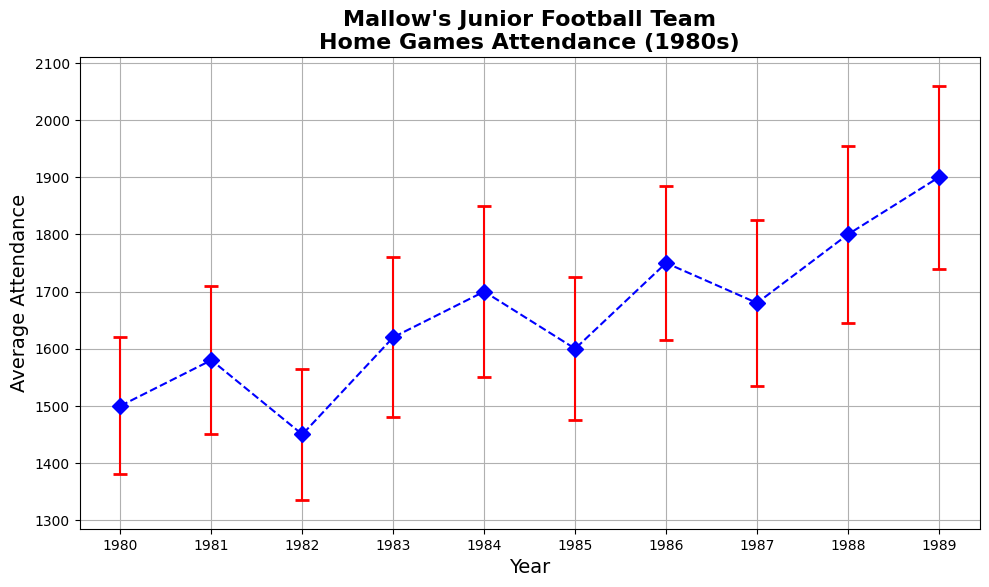What was the average attendance in 1984? Look at the data point for 1984 and note the average attendance value.
Answer: 1700 Which year had the highest average attendance? Compare the average attendance values for all the years and identify the highest value.
Answer: 1989 Between 1980 and 1985, in which year did the attendance fluctuate the most? Check the standard deviation values for the years 1980 to 1985 and identify the highest one, which indicates the maximum fluctuation.
Answer: 1984 What's the total average attendance for the years 1983 and 1984? Sum the average attendance values for 1983 and 1984.
Answer: 3320 (1620 + 1700) Are there any years where the average attendance value decreases compared to the previous year? Compare the average attendance values year by year and identify any year where the value is less than the previous year's value.
Answer: Yes, 1982 What is the difference in average attendance between 1989 and 1980? Subtract the average attendance value of 1980 from the average attendance value of 1989.
Answer: 400 (1900 - 1500) In which year did the average attendance first exceed 1600? Check the average attendance values for each year and identify the first year where the value is greater than 1600.
Answer: 1983 How much did the average attendance increase from 1982 to 1983? Subtract the average attendance value of 1982 from that of 1983.
Answer: 170 (1620 - 1450) Which years have a standard deviation greater than 140? Identify the years where the standard deviation value is higher than 140.
Answer: 1983, 1984, 1987, 1988, 1989 What are the color and style of the line connecting the data points with error bars? Observe the figure and note the color and line style connecting the data points.
Answer: Blue, dashed line 